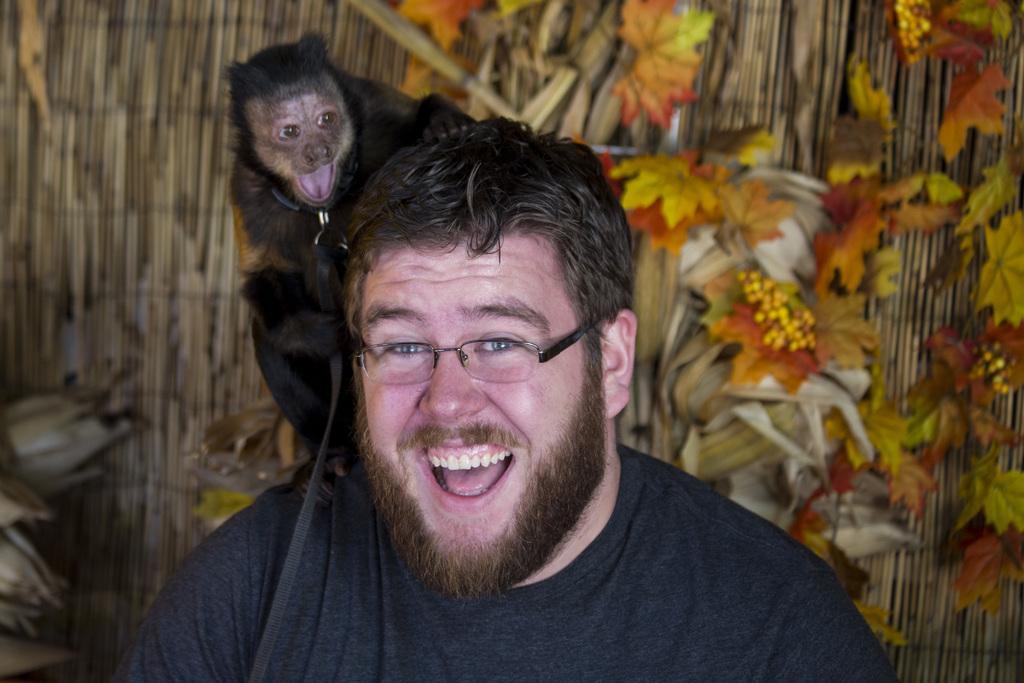Can you describe this image briefly? A black color animal is sitting on the neck of a man. He is smiling. 